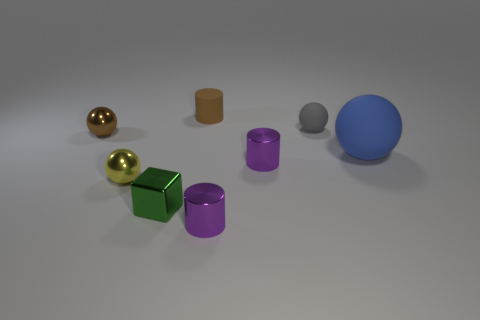What number of other things are there of the same material as the small brown sphere
Your answer should be compact. 4. What is the size of the blue matte thing that is the same shape as the tiny gray thing?
Offer a terse response. Large. Is the tiny sphere right of the tiny brown cylinder made of the same material as the tiny purple thing behind the yellow sphere?
Your answer should be compact. No. Are there fewer matte things that are to the left of the brown rubber cylinder than large objects?
Provide a succinct answer. Yes. Are there any other things that are the same shape as the tiny brown metallic thing?
Ensure brevity in your answer.  Yes. The other matte object that is the same shape as the large blue object is what color?
Offer a terse response. Gray. Do the purple cylinder that is in front of the yellow metallic ball and the blue matte sphere have the same size?
Make the answer very short. No. What size is the purple cylinder on the right side of the small metallic cylinder in front of the green metal thing?
Make the answer very short. Small. Are the small brown sphere and the small ball in front of the blue matte ball made of the same material?
Your answer should be compact. Yes. Is the number of small blocks on the right side of the gray rubber thing less than the number of small gray spheres that are in front of the brown ball?
Offer a very short reply. No. 